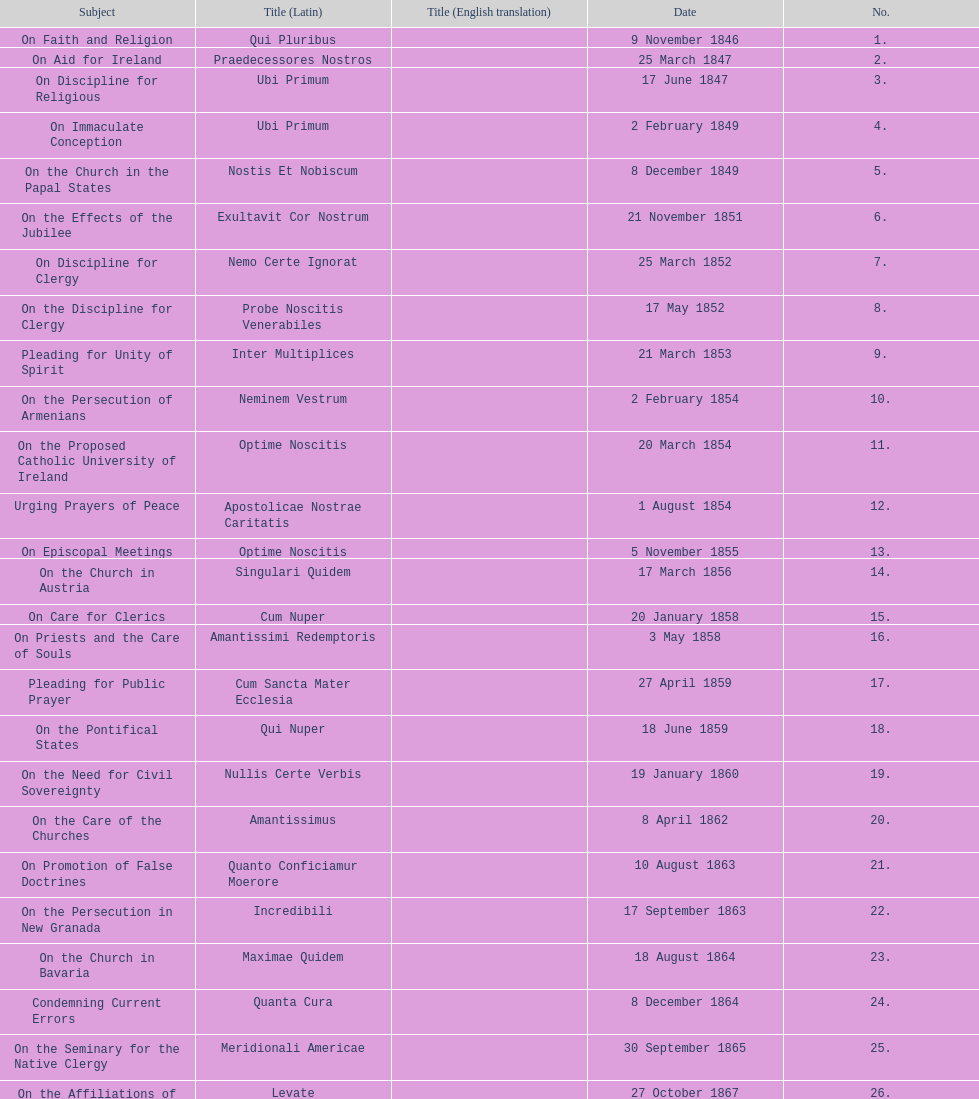Parse the table in full. {'header': ['Subject', 'Title (Latin)', 'Title (English translation)', 'Date', 'No.'], 'rows': [['On Faith and Religion', 'Qui Pluribus', '', '9 November 1846', '1.'], ['On Aid for Ireland', 'Praedecessores Nostros', '', '25 March 1847', '2.'], ['On Discipline for Religious', 'Ubi Primum', '', '17 June 1847', '3.'], ['On Immaculate Conception', 'Ubi Primum', '', '2 February 1849', '4.'], ['On the Church in the Papal States', 'Nostis Et Nobiscum', '', '8 December 1849', '5.'], ['On the Effects of the Jubilee', 'Exultavit Cor Nostrum', '', '21 November 1851', '6.'], ['On Discipline for Clergy', 'Nemo Certe Ignorat', '', '25 March 1852', '7.'], ['On the Discipline for Clergy', 'Probe Noscitis Venerabiles', '', '17 May 1852', '8.'], ['Pleading for Unity of Spirit', 'Inter Multiplices', '', '21 March 1853', '9.'], ['On the Persecution of Armenians', 'Neminem Vestrum', '', '2 February 1854', '10.'], ['On the Proposed Catholic University of Ireland', 'Optime Noscitis', '', '20 March 1854', '11.'], ['Urging Prayers of Peace', 'Apostolicae Nostrae Caritatis', '', '1 August 1854', '12.'], ['On Episcopal Meetings', 'Optime Noscitis', '', '5 November 1855', '13.'], ['On the Church in Austria', 'Singulari Quidem', '', '17 March 1856', '14.'], ['On Care for Clerics', 'Cum Nuper', '', '20 January 1858', '15.'], ['On Priests and the Care of Souls', 'Amantissimi Redemptoris', '', '3 May 1858', '16.'], ['Pleading for Public Prayer', 'Cum Sancta Mater Ecclesia', '', '27 April 1859', '17.'], ['On the Pontifical States', 'Qui Nuper', '', '18 June 1859', '18.'], ['On the Need for Civil Sovereignty', 'Nullis Certe Verbis', '', '19 January 1860', '19.'], ['On the Care of the Churches', 'Amantissimus', '', '8 April 1862', '20.'], ['On Promotion of False Doctrines', 'Quanto Conficiamur Moerore', '', '10 August 1863', '21.'], ['On the Persecution in New Granada', 'Incredibili', '', '17 September 1863', '22.'], ['On the Church in Bavaria', 'Maximae Quidem', '', '18 August 1864', '23.'], ['Condemning Current Errors', 'Quanta Cura', '', '8 December 1864', '24.'], ['On the Seminary for the Native Clergy', 'Meridionali Americae', '', '30 September 1865', '25.'], ['On the Affiliations of Church', 'Levate', '', '27 October 1867', '26.'], ['Protesting the Taking of the Pontifical States', 'Respicientes', '', '1 November 1870', '27.'], ['On the Pontifical States', 'Ubi Nos', '"Our City"', '15 May 1871', '28.'], ['On the 25th Anniversary of His Pontificate', 'Beneficia Dei', '', '4 June 1871', '29.'], ['Thanksgiving for 25 Years of Pontificate', 'Saepe Venerabiles Fratres', '', '5 August 1871', '30.'], ['On the Church in Chaldea', 'Quae In Patriarchatu', '', '16 November 1872', '31.'], ['On the Church in Armenia', 'Quartus Supra', '', 'January 1873', '32.'], ['On the Church in Italy, Germany and Switzerland', 'Etsi Multa', '', '21 November 1873', '33.'], ['On the Church in Austria', 'Vix Dum A Nobis', '', '7 March 1874', '34.'], ['On the Greek-Ruthenian Rite', 'Omnem Sollicitudinem', '', '13 May 1874', '35.'], ['Proclaiming A Jubilee', 'Gravibus Ecclesiae', '', '24 December 1874', '36.'], ['On the Church in Prussia', 'Quod Nunquam', '', '5 February 1875', '37.'], ['On the Church in Switzerland', 'Graves Ac Diuturnae', '', '23 March 1875', '38.']]} What is the total number of title? 38. 